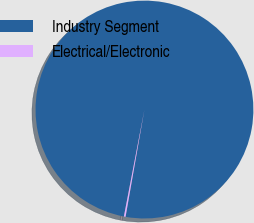Convert chart. <chart><loc_0><loc_0><loc_500><loc_500><pie_chart><fcel>Industry Segment<fcel>Electrical/Electronic<nl><fcel>99.75%<fcel>0.25%<nl></chart> 